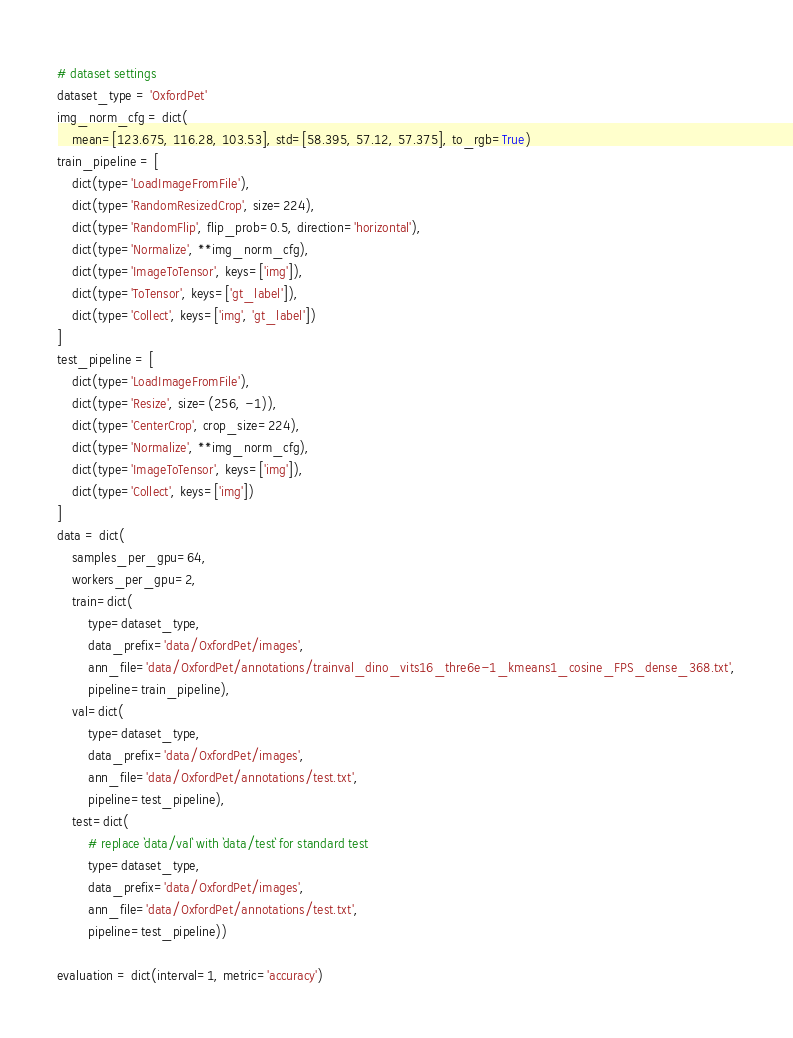<code> <loc_0><loc_0><loc_500><loc_500><_Python_># dataset settings
dataset_type = 'OxfordPet'
img_norm_cfg = dict(
    mean=[123.675, 116.28, 103.53], std=[58.395, 57.12, 57.375], to_rgb=True)
train_pipeline = [
    dict(type='LoadImageFromFile'),
    dict(type='RandomResizedCrop', size=224),
    dict(type='RandomFlip', flip_prob=0.5, direction='horizontal'),
    dict(type='Normalize', **img_norm_cfg),
    dict(type='ImageToTensor', keys=['img']),
    dict(type='ToTensor', keys=['gt_label']),
    dict(type='Collect', keys=['img', 'gt_label'])
]
test_pipeline = [
    dict(type='LoadImageFromFile'),
    dict(type='Resize', size=(256, -1)),
    dict(type='CenterCrop', crop_size=224),
    dict(type='Normalize', **img_norm_cfg),
    dict(type='ImageToTensor', keys=['img']),
    dict(type='Collect', keys=['img'])
]
data = dict(
    samples_per_gpu=64,
    workers_per_gpu=2,
    train=dict(
        type=dataset_type,
        data_prefix='data/OxfordPet/images',
        ann_file='data/OxfordPet/annotations/trainval_dino_vits16_thre6e-1_kmeans1_cosine_FPS_dense_368.txt',
        pipeline=train_pipeline),
    val=dict(
        type=dataset_type,
        data_prefix='data/OxfordPet/images',
        ann_file='data/OxfordPet/annotations/test.txt',
        pipeline=test_pipeline),
    test=dict(
        # replace `data/val` with `data/test` for standard test
        type=dataset_type,
        data_prefix='data/OxfordPet/images',
        ann_file='data/OxfordPet/annotations/test.txt',
        pipeline=test_pipeline))

evaluation = dict(interval=1, metric='accuracy')
</code> 